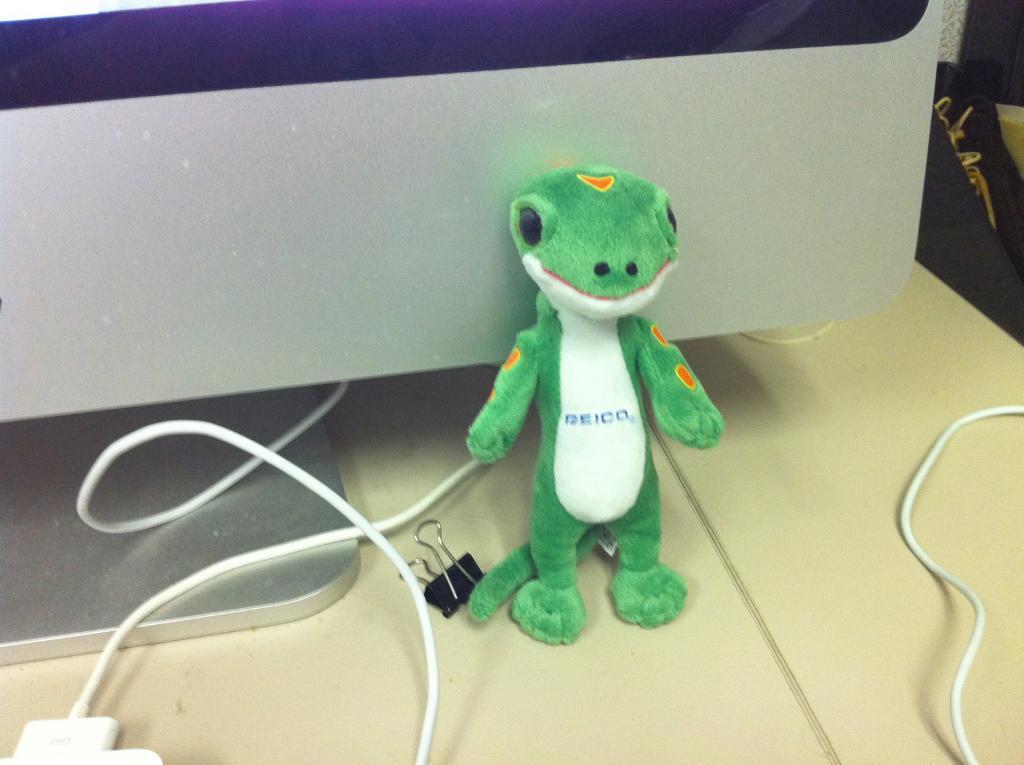Please provide a concise description of this image. There is a toy, clip and wires on a surface. In the back there is a monitor. 